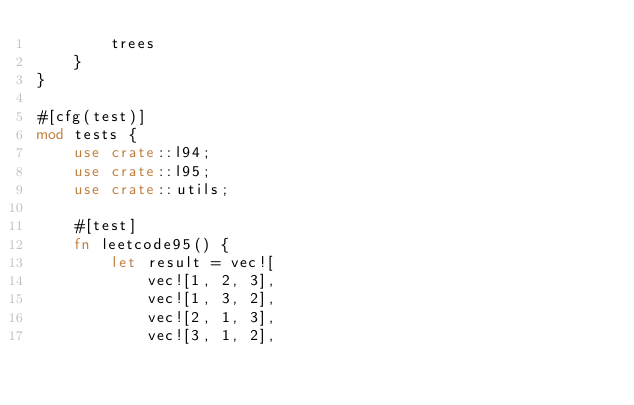<code> <loc_0><loc_0><loc_500><loc_500><_Rust_>        trees
    }
}

#[cfg(test)]
mod tests {
    use crate::l94;
    use crate::l95;
    use crate::utils;

    #[test]
    fn leetcode95() {
        let result = vec![
            vec![1, 2, 3],
            vec![1, 3, 2],
            vec![2, 1, 3],
            vec![3, 1, 2],</code> 